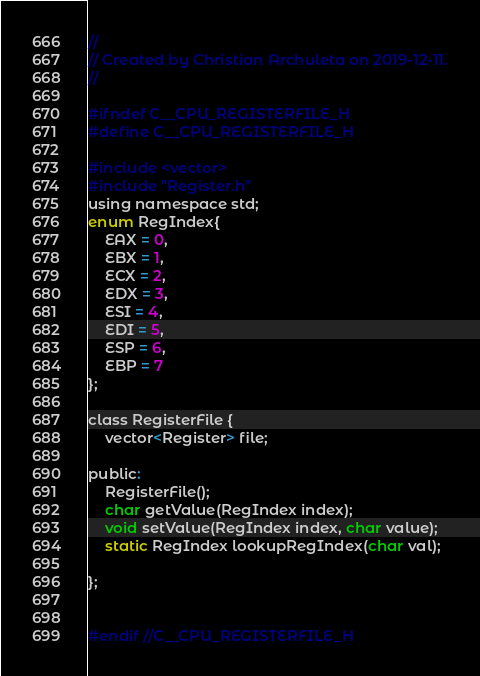<code> <loc_0><loc_0><loc_500><loc_500><_C_>//
// Created by Christian Archuleta on 2019-12-11.
//

#ifndef C__CPU_REGISTERFILE_H
#define C__CPU_REGISTERFILE_H

#include <vector>
#include "Register.h"
using namespace std;
enum RegIndex{
    EAX = 0,
    EBX = 1,
    ECX = 2,
    EDX = 3,
    ESI = 4,
    EDI = 5,
    ESP = 6,
    EBP = 7
};

class RegisterFile {
    vector<Register> file;

public:
    RegisterFile();
    char getValue(RegIndex index);
    void setValue(RegIndex index, char value);
    static RegIndex lookupRegIndex(char val);

};


#endif //C__CPU_REGISTERFILE_H
</code> 